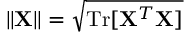<formula> <loc_0><loc_0><loc_500><loc_500>\| { X } \| = \sqrt { T r [ { X } ^ { T } { X } ] }</formula> 